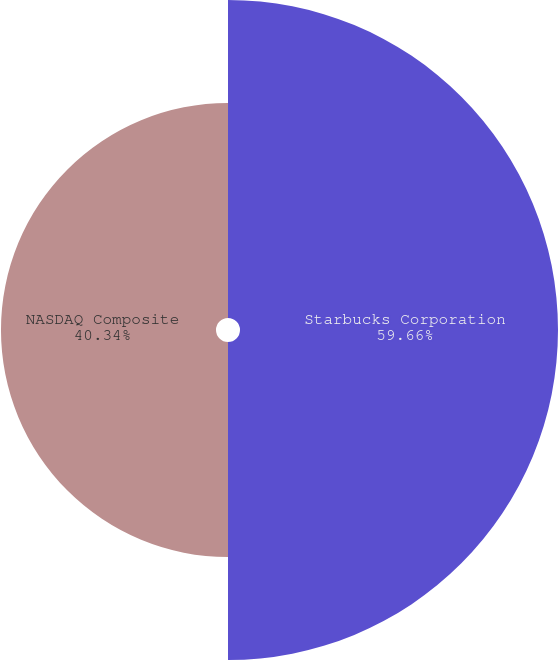Convert chart. <chart><loc_0><loc_0><loc_500><loc_500><pie_chart><fcel>Starbucks Corporation<fcel>NASDAQ Composite<nl><fcel>59.66%<fcel>40.34%<nl></chart> 